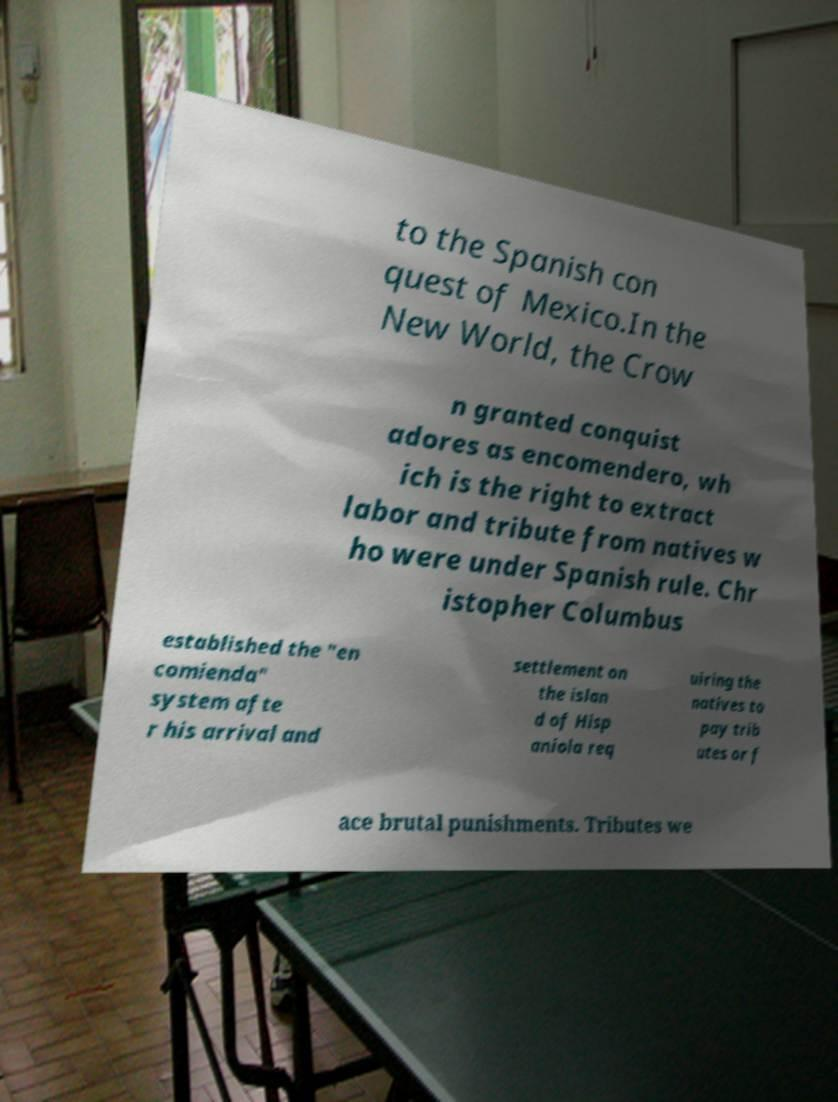Could you extract and type out the text from this image? to the Spanish con quest of Mexico.In the New World, the Crow n granted conquist adores as encomendero, wh ich is the right to extract labor and tribute from natives w ho were under Spanish rule. Chr istopher Columbus established the "en comienda" system afte r his arrival and settlement on the islan d of Hisp aniola req uiring the natives to pay trib utes or f ace brutal punishments. Tributes we 